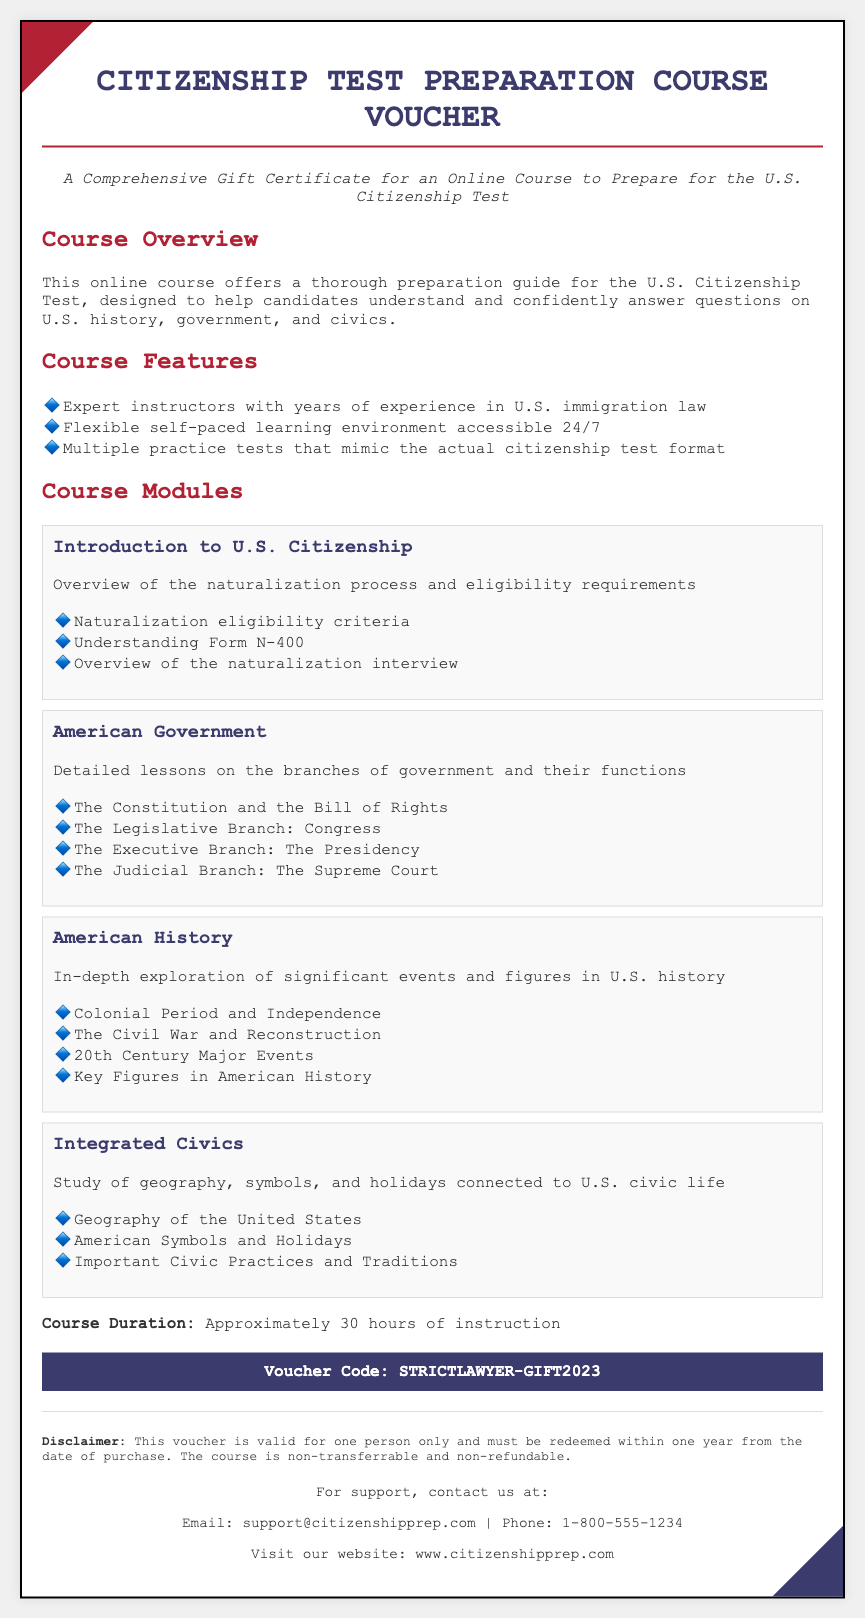What is the title of the voucher? The title of the voucher is prominently displayed at the top of the document.
Answer: Citizenship Test Preparation Course Voucher What is the course duration? The course duration is specified within the document's details.
Answer: Approximately 30 hours of instruction What is the module that covers U.S. geography? The specific module addressing U.S. geography is listed under course modules.
Answer: Integrated Civics Who can support you if you have questions? The contact information for support is provided in the footer of the document.
Answer: support@citizenshipprep.com What is the voucher code? The voucher code is highlighted in a distinctive section of the voucher.
Answer: STRICTLAWYER-GIFT2023 What is the eligibility requirement topic covered in the course? The overview of eligibility requirements is stated in one of the modules.
Answer: Naturalization eligibility criteria Name one feature of the course. The features of the course are listed in a bulleted format within the document.
Answer: Expert instructors with years of experience in U.S. immigration law What type of course is this? The type of course is indicated in the introductory description.
Answer: Online Course 